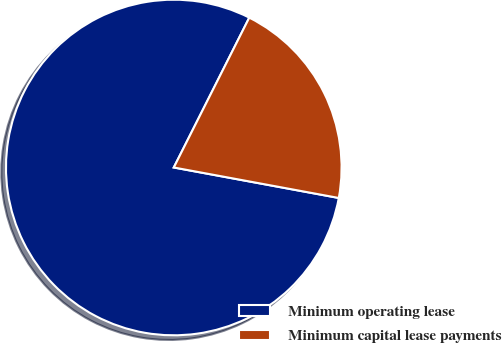<chart> <loc_0><loc_0><loc_500><loc_500><pie_chart><fcel>Minimum operating lease<fcel>Minimum capital lease payments<nl><fcel>79.52%<fcel>20.48%<nl></chart> 